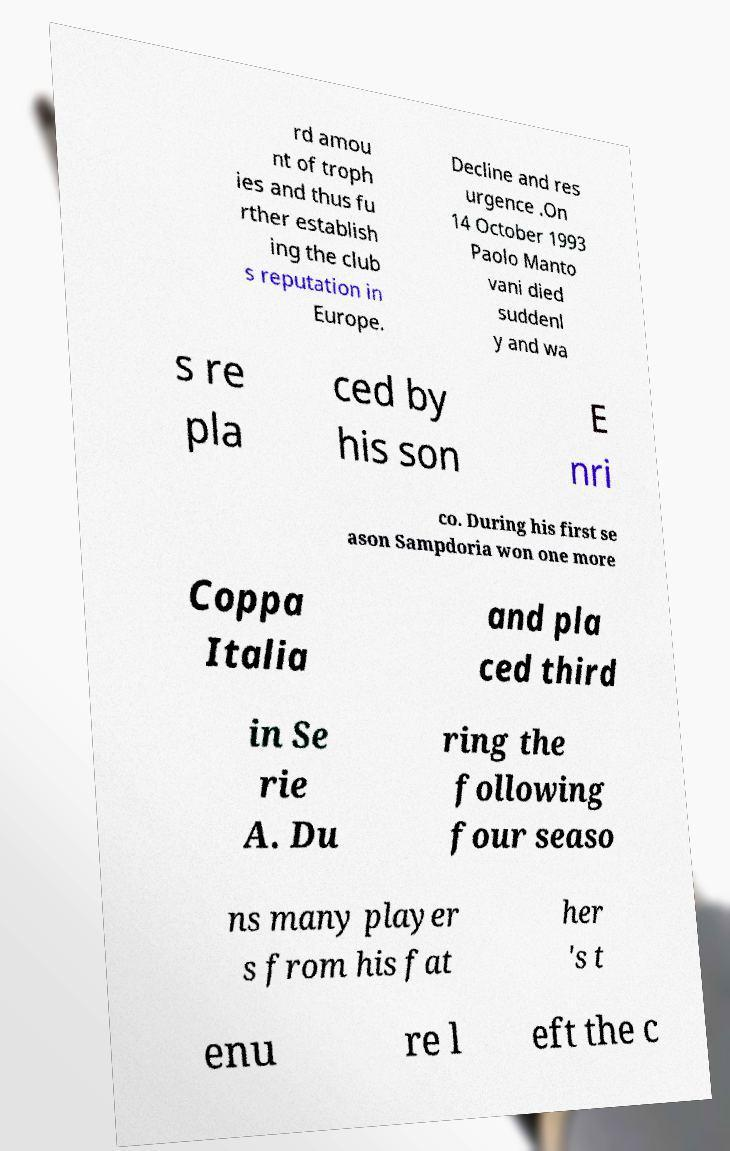Could you extract and type out the text from this image? rd amou nt of troph ies and thus fu rther establish ing the club s reputation in Europe. Decline and res urgence .On 14 October 1993 Paolo Manto vani died suddenl y and wa s re pla ced by his son E nri co. During his first se ason Sampdoria won one more Coppa Italia and pla ced third in Se rie A. Du ring the following four seaso ns many player s from his fat her 's t enu re l eft the c 